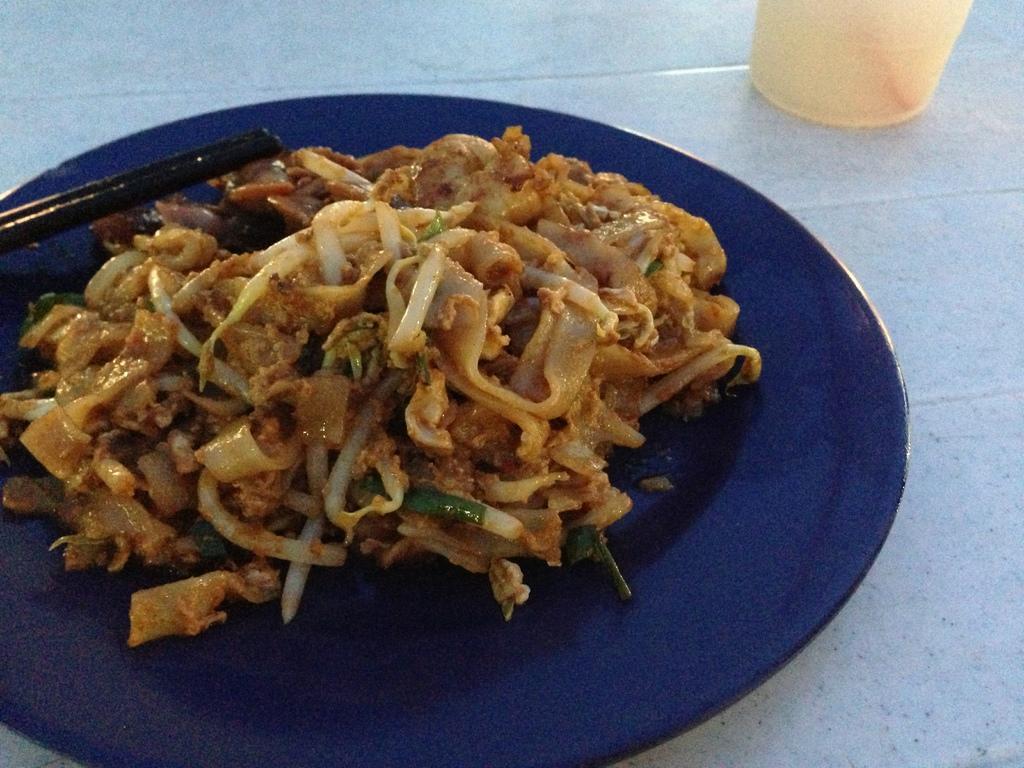Could you give a brief overview of what you see in this image? In this image we can see a food item on a plate. The plate is on the white color surface. We can see a glass at the top of the image. We can see two sticks on the left side of the image. 